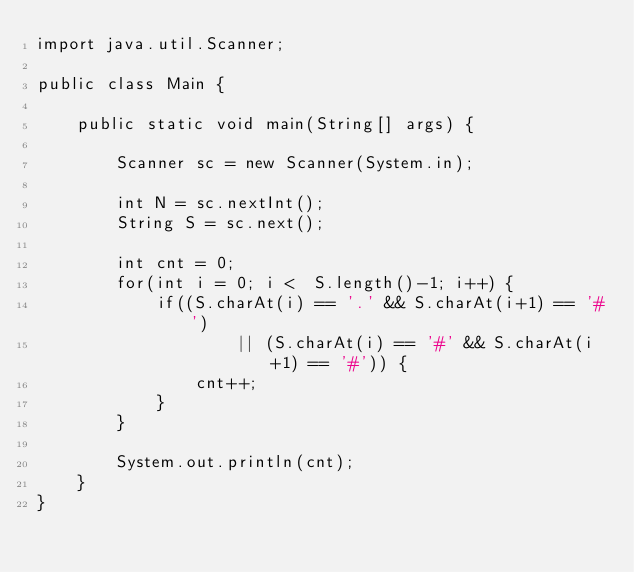Convert code to text. <code><loc_0><loc_0><loc_500><loc_500><_Java_>import java.util.Scanner;

public class Main {

	public static void main(String[] args) {

		Scanner sc = new Scanner(System.in);

		int N = sc.nextInt();
		String S = sc.next();
		
		int cnt = 0;
		for(int i = 0; i <  S.length()-1; i++) {
			if((S.charAt(i) == '.' && S.charAt(i+1) == '#')
					|| (S.charAt(i) == '#' && S.charAt(i+1) == '#')) {
				cnt++;
			}
		}
		
		System.out.println(cnt);
	}
}</code> 